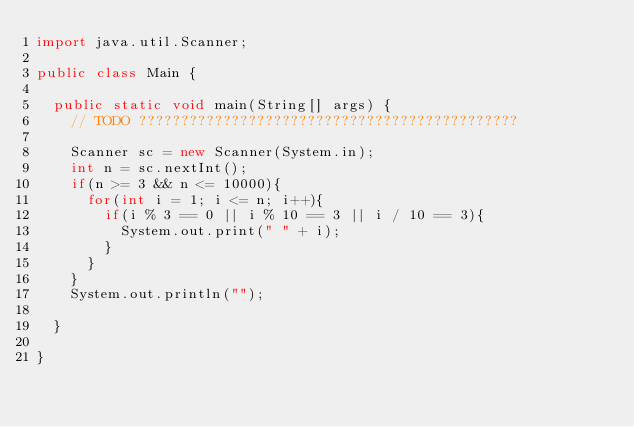Convert code to text. <code><loc_0><loc_0><loc_500><loc_500><_Java_>import java.util.Scanner;

public class Main {

	public static void main(String[] args) {
		// TODO ?????????????????????????????????????????????

		Scanner sc = new Scanner(System.in);
		int n = sc.nextInt();
		if(n >= 3 && n <= 10000){
			for(int i = 1; i <= n; i++){
				if(i % 3 == 0 || i % 10 == 3 || i / 10 == 3){
					System.out.print(" " + i);
				}
			}
		}
		System.out.println("");

	}

}</code> 